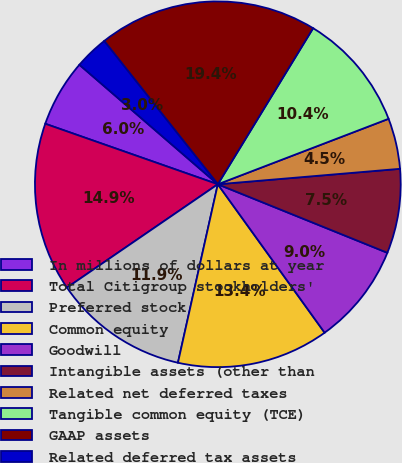Convert chart. <chart><loc_0><loc_0><loc_500><loc_500><pie_chart><fcel>In millions of dollars at year<fcel>Total Citigroup stockholders'<fcel>Preferred stock<fcel>Common equity<fcel>Goodwill<fcel>Intangible assets (other than<fcel>Related net deferred taxes<fcel>Tangible common equity (TCE)<fcel>GAAP assets<fcel>Related deferred tax assets<nl><fcel>5.97%<fcel>14.93%<fcel>11.94%<fcel>13.43%<fcel>8.96%<fcel>7.46%<fcel>4.48%<fcel>10.45%<fcel>19.4%<fcel>2.99%<nl></chart> 